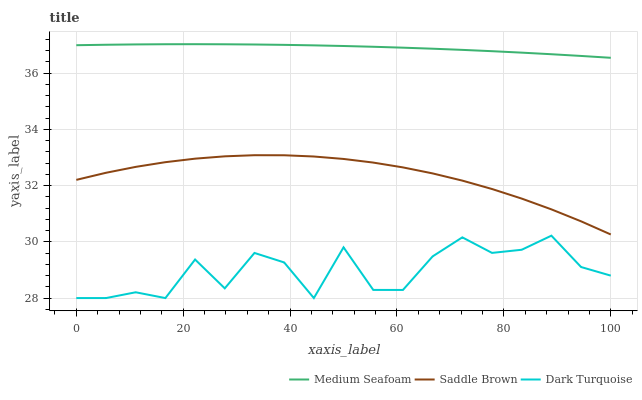Does Saddle Brown have the minimum area under the curve?
Answer yes or no. No. Does Saddle Brown have the maximum area under the curve?
Answer yes or no. No. Is Saddle Brown the smoothest?
Answer yes or no. No. Is Saddle Brown the roughest?
Answer yes or no. No. Does Saddle Brown have the lowest value?
Answer yes or no. No. Does Saddle Brown have the highest value?
Answer yes or no. No. Is Dark Turquoise less than Medium Seafoam?
Answer yes or no. Yes. Is Saddle Brown greater than Dark Turquoise?
Answer yes or no. Yes. Does Dark Turquoise intersect Medium Seafoam?
Answer yes or no. No. 